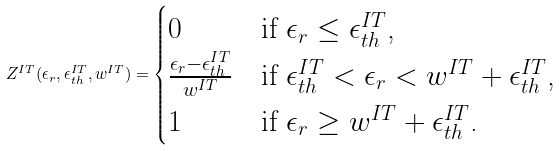Convert formula to latex. <formula><loc_0><loc_0><loc_500><loc_500>Z ^ { I T } ( \epsilon _ { r } , \epsilon _ { t h } ^ { I T } , w ^ { I T } ) = \begin{cases} 0 & \text {if $\epsilon_{r}\leq\epsilon_{th}^{IT}$,} \\ \frac { \epsilon _ { r } - \epsilon _ { t h } ^ { I T } } { w ^ { I T } } & \text {if $\epsilon_{th}^{IT}<\epsilon_{r} < w^{IT}+\epsilon_{th}^{IT}$,} \\ 1 & \text {if $\epsilon_{r} \geq w^{IT}+\epsilon_{th}^{IT}$.} \end{cases}</formula> 